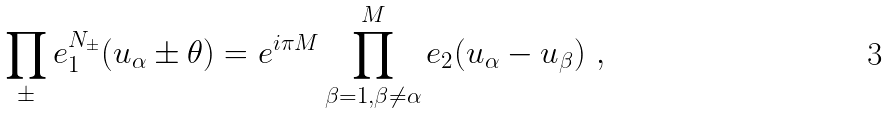<formula> <loc_0><loc_0><loc_500><loc_500>\prod _ { \pm } e _ { 1 } ^ { N _ { \pm } } ( u _ { \alpha } \pm \theta ) = e ^ { i \pi M } \prod _ { \beta = 1 , \beta \ne \alpha } ^ { M } e _ { 2 } ( u _ { \alpha } - u _ { \beta } ) \ ,</formula> 